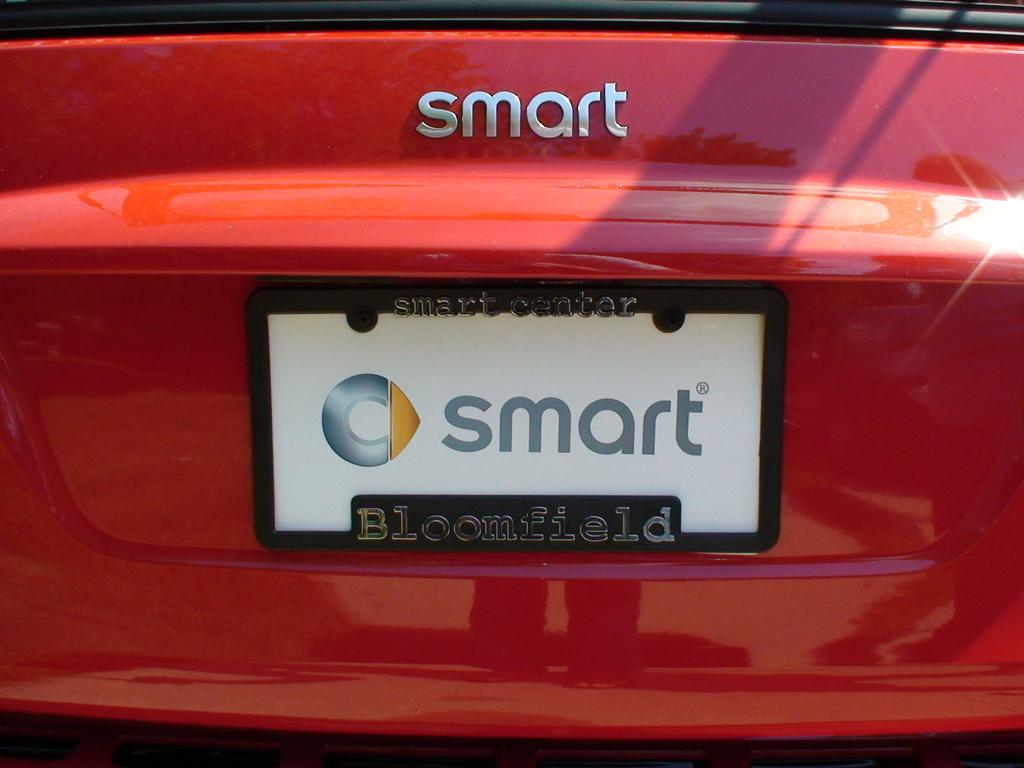<image>
Provide a brief description of the given image. A smart brand car has a Bloomfield license plate holder. 